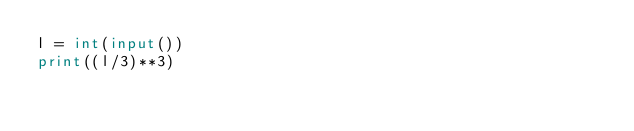Convert code to text. <code><loc_0><loc_0><loc_500><loc_500><_Python_>l = int(input())
print((l/3)**3)</code> 